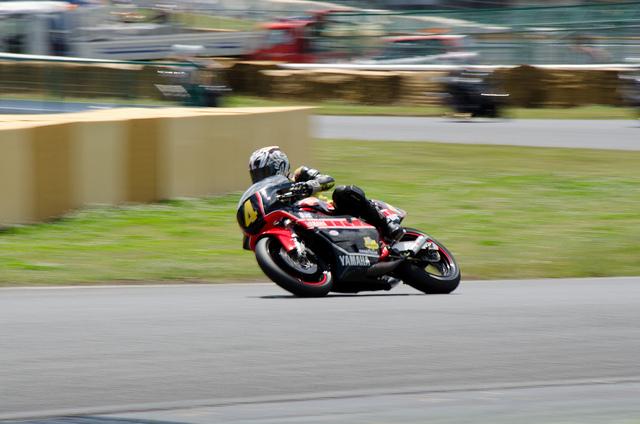What is the number on the front of this motorcycle?
Answer briefly. 4. What computer company is on the black bike?
Keep it brief. Yamaha. Which way is the bike leaning?
Quick response, please. Right. Is he wearing a helmet?
Give a very brief answer. Yes. 